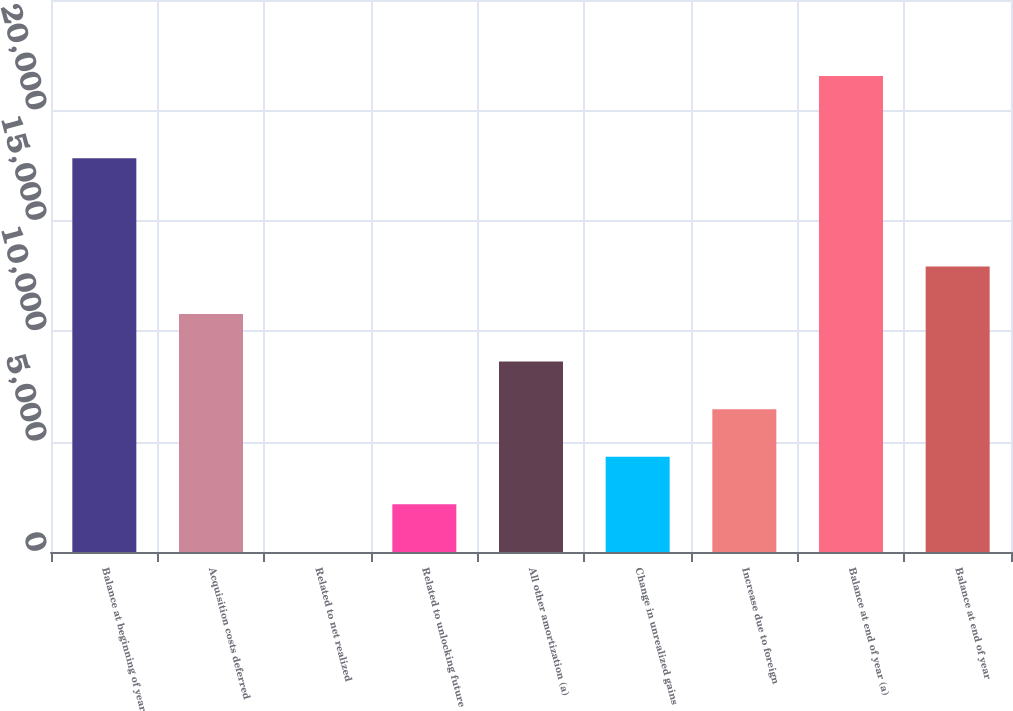Convert chart to OTSL. <chart><loc_0><loc_0><loc_500><loc_500><bar_chart><fcel>Balance at beginning of year<fcel>Acquisition costs deferred<fcel>Related to net realized<fcel>Related to unlocking future<fcel>All other amortization (a)<fcel>Change in unrealized gains<fcel>Increase due to foreign<fcel>Balance at end of year (a)<fcel>Balance at end of year<nl><fcel>17830<fcel>10779.5<fcel>2<fcel>2157.5<fcel>8624<fcel>4313<fcel>6468.5<fcel>21557<fcel>12935<nl></chart> 